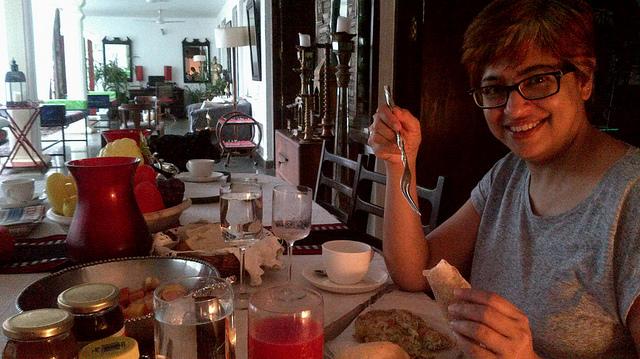Is the man probably in a restaurant or at home?
Be succinct. Restaurant. What is this person doing?
Answer briefly. Eating. What type of wine is in the glass?
Give a very brief answer. White. Is there a man in this photo?
Quick response, please. No. 